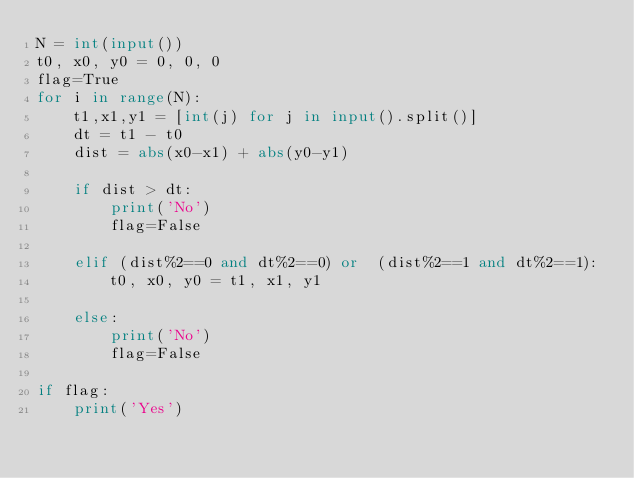<code> <loc_0><loc_0><loc_500><loc_500><_Python_>N = int(input())
t0, x0, y0 = 0, 0, 0
flag=True
for i in range(N):
    t1,x1,y1 = [int(j) for j in input().split()]
    dt = t1 - t0
    dist = abs(x0-x1) + abs(y0-y1)

    if dist > dt:
        print('No')
        flag=False

    elif (dist%2==0 and dt%2==0) or  (dist%2==1 and dt%2==1):
        t0, x0, y0 = t1, x1, y1

    else:
        print('No')
        flag=False

if flag:
    print('Yes')</code> 